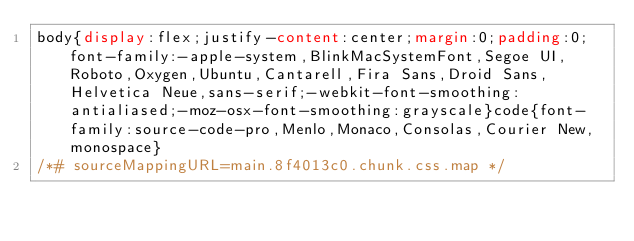Convert code to text. <code><loc_0><loc_0><loc_500><loc_500><_CSS_>body{display:flex;justify-content:center;margin:0;padding:0;font-family:-apple-system,BlinkMacSystemFont,Segoe UI,Roboto,Oxygen,Ubuntu,Cantarell,Fira Sans,Droid Sans,Helvetica Neue,sans-serif;-webkit-font-smoothing:antialiased;-moz-osx-font-smoothing:grayscale}code{font-family:source-code-pro,Menlo,Monaco,Consolas,Courier New,monospace}
/*# sourceMappingURL=main.8f4013c0.chunk.css.map */</code> 